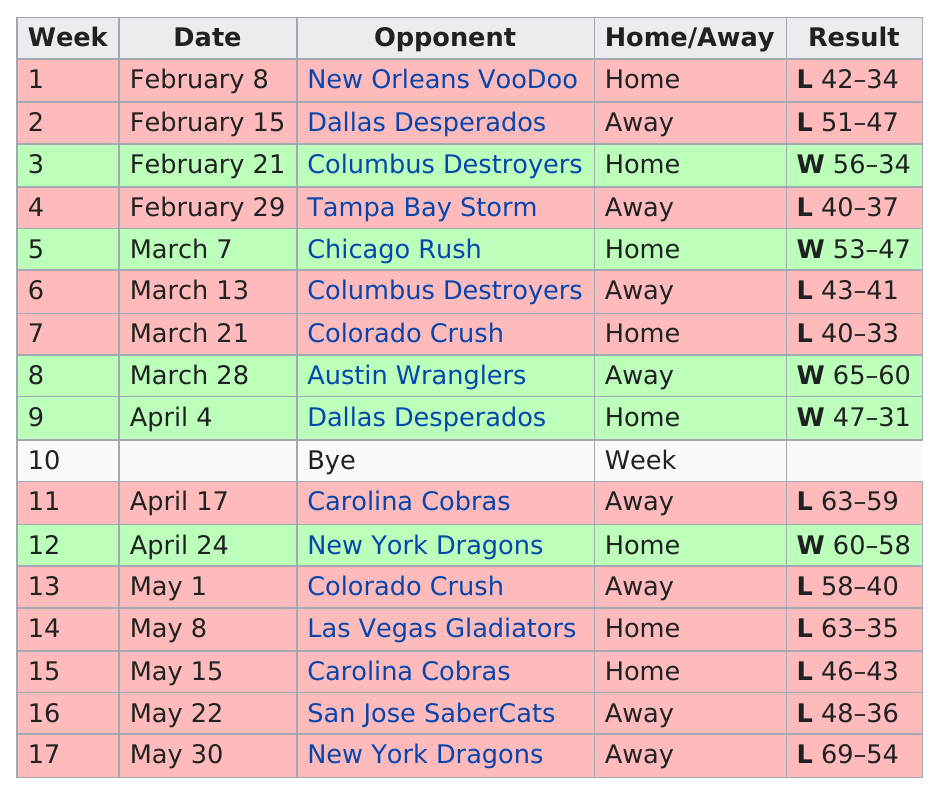Mention a couple of crucial points in this snapshot. After playing the Chicago Rush, the Philadelphia Soul had their next opponent as the Columbus Destroyers. I want to know the total number of games lost during the month of April. Can you please provide me with the information? The team lost a total of 7 times while on the road. In total, there have been eight home games played. After the bye week, the Philadelphia Soul lost a total of six games. 